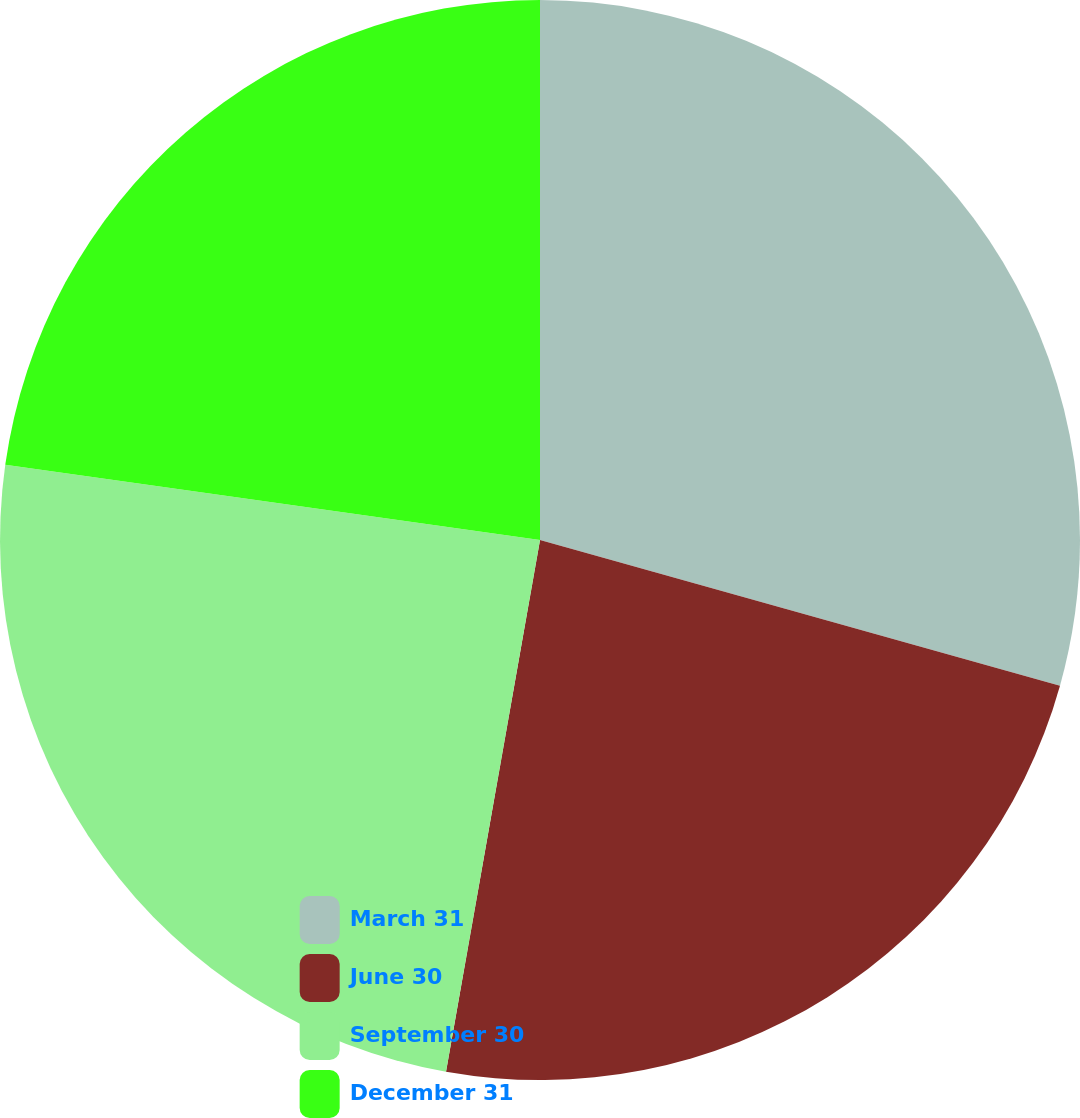Convert chart. <chart><loc_0><loc_0><loc_500><loc_500><pie_chart><fcel>March 31<fcel>June 30<fcel>September 30<fcel>December 31<nl><fcel>29.35%<fcel>23.44%<fcel>24.44%<fcel>22.78%<nl></chart> 